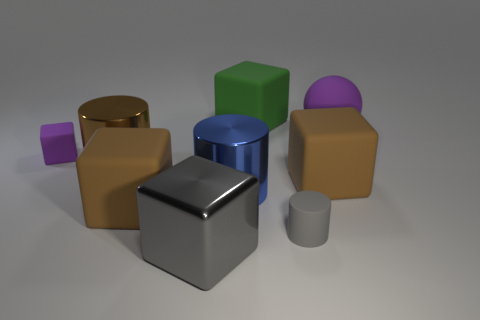There is a gray thing in front of the small rubber cylinder; is it the same shape as the gray matte thing?
Provide a succinct answer. No. What material is the small cylinder?
Your response must be concise. Rubber. What is the shape of the green matte object that is the same size as the purple sphere?
Give a very brief answer. Cube. Are there any metal things that have the same color as the large sphere?
Give a very brief answer. No. Do the ball and the tiny matte object that is to the left of the blue metallic thing have the same color?
Give a very brief answer. Yes. There is a small object on the right side of the large metallic object in front of the large blue cylinder; what color is it?
Keep it short and to the point. Gray. Are there any big metallic cubes that are behind the brown rubber thing in front of the brown rubber cube on the right side of the large green thing?
Give a very brief answer. No. The small cylinder that is made of the same material as the large green object is what color?
Keep it short and to the point. Gray. What number of big cyan things have the same material as the small cylinder?
Ensure brevity in your answer.  0. Are the tiny gray cylinder and the tiny object that is on the left side of the large brown metal cylinder made of the same material?
Your answer should be compact. Yes. 